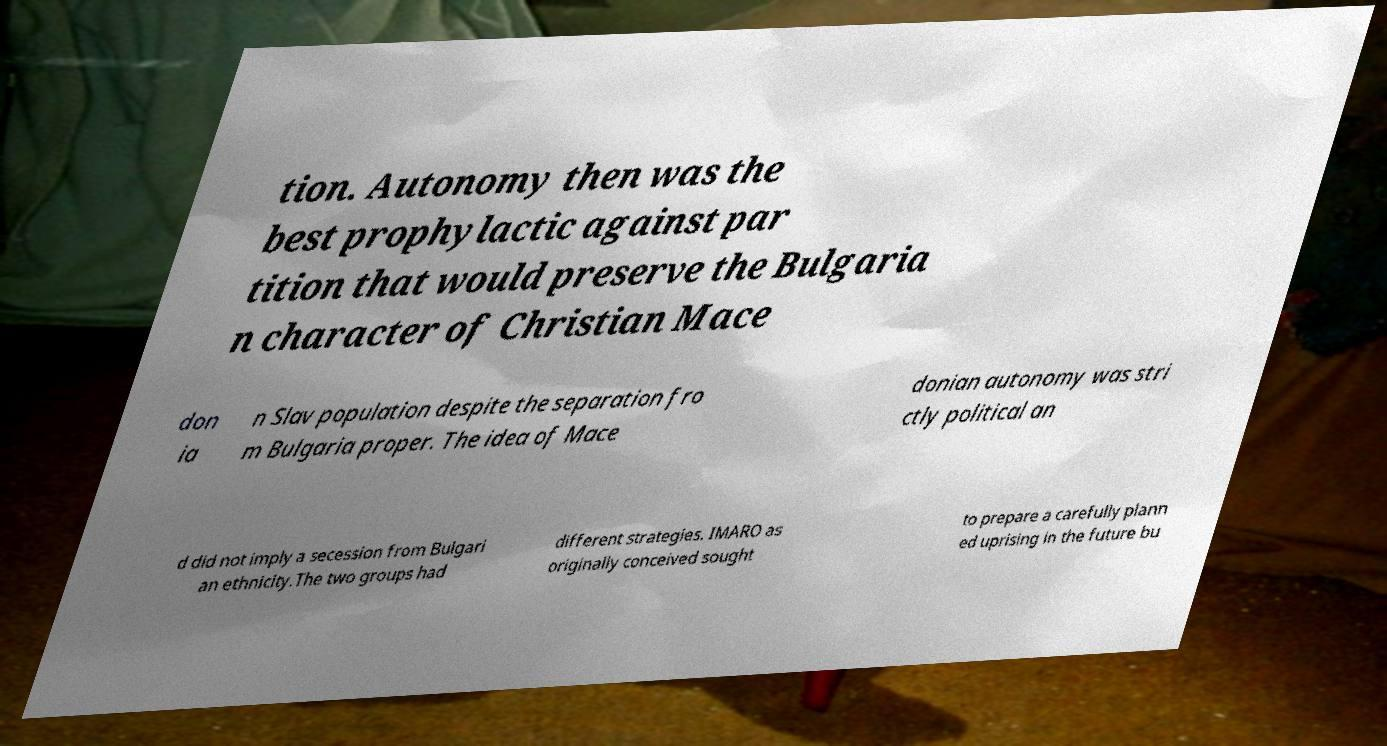Please identify and transcribe the text found in this image. tion. Autonomy then was the best prophylactic against par tition that would preserve the Bulgaria n character of Christian Mace don ia n Slav population despite the separation fro m Bulgaria proper. The idea of Mace donian autonomy was stri ctly political an d did not imply a secession from Bulgari an ethnicity.The two groups had different strategies. IMARO as originally conceived sought to prepare a carefully plann ed uprising in the future bu 